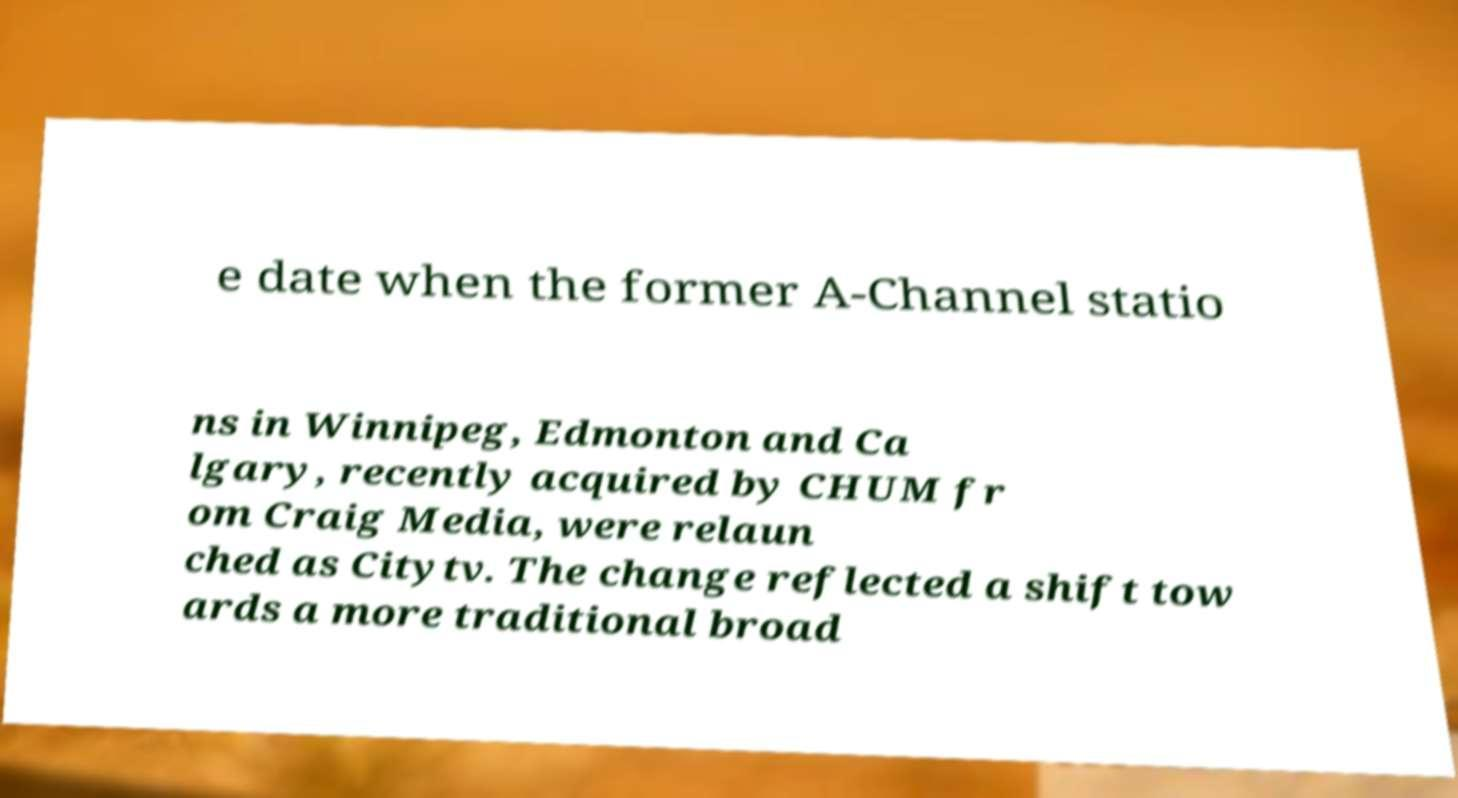For documentation purposes, I need the text within this image transcribed. Could you provide that? e date when the former A-Channel statio ns in Winnipeg, Edmonton and Ca lgary, recently acquired by CHUM fr om Craig Media, were relaun ched as Citytv. The change reflected a shift tow ards a more traditional broad 